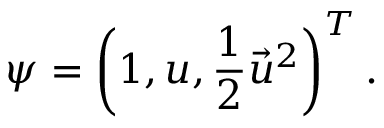<formula> <loc_0><loc_0><loc_500><loc_500>\psi = \left ( 1 , u , \frac { 1 } { 2 } { \vec { u } } ^ { 2 } \right ) ^ { T } .</formula> 